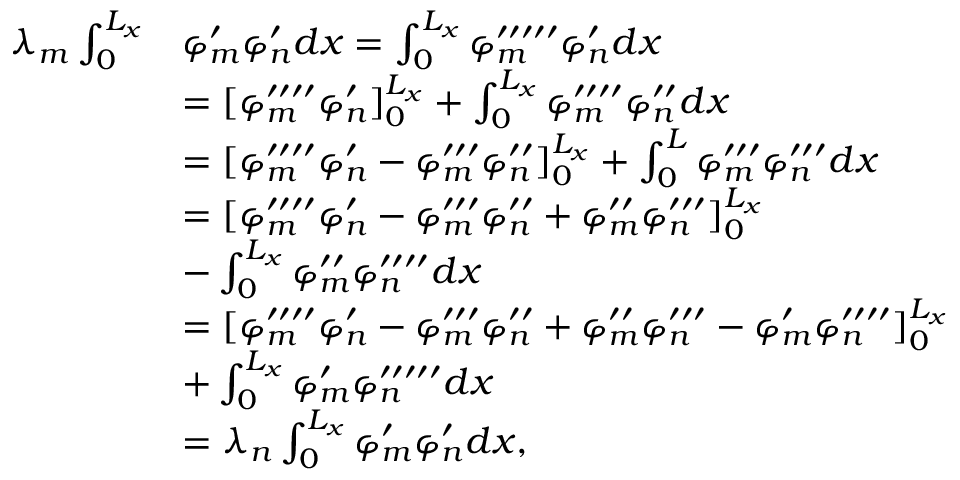Convert formula to latex. <formula><loc_0><loc_0><loc_500><loc_500>\begin{array} { r l } { \lambda _ { m } \int _ { 0 } ^ { L _ { x } } } & { \varphi _ { m } ^ { \prime } \varphi _ { n } ^ { \prime } d x = \int _ { 0 } ^ { L _ { x } } \varphi _ { m } ^ { \prime \prime \prime \prime \prime } \varphi _ { n } ^ { \prime } d x } \\ & { = [ \varphi _ { m } ^ { \prime \prime \prime \prime } \varphi _ { n } ^ { \prime } ] _ { 0 } ^ { L _ { x } } + \int _ { 0 } ^ { L _ { x } } \varphi _ { m } ^ { \prime \prime \prime \prime } \varphi _ { n } ^ { \prime \prime } d x } \\ & { = [ \varphi _ { m } ^ { \prime \prime \prime \prime } \varphi _ { n } ^ { \prime } - \varphi _ { m } ^ { \prime \prime \prime } \varphi _ { n } ^ { \prime \prime } ] _ { 0 } ^ { L _ { x } } + \int _ { 0 } ^ { L } \varphi _ { m } ^ { \prime \prime \prime } \varphi _ { n } ^ { \prime \prime \prime } d x } \\ & { = [ \varphi _ { m } ^ { \prime \prime \prime \prime } \varphi _ { n } ^ { \prime } - \varphi _ { m } ^ { \prime \prime \prime } \varphi _ { n } ^ { \prime \prime } + \varphi _ { m } ^ { \prime \prime } \varphi _ { n } ^ { \prime \prime \prime } ] _ { 0 } ^ { L _ { x } } } \\ & { - \int _ { 0 } ^ { L _ { x } } \varphi _ { m } ^ { \prime \prime } \varphi _ { n } ^ { \prime \prime \prime \prime } d x } \\ & { = [ \varphi _ { m } ^ { \prime \prime \prime \prime } \varphi _ { n } ^ { \prime } - \varphi _ { m } ^ { \prime \prime \prime } \varphi _ { n } ^ { \prime \prime } + \varphi _ { m } ^ { \prime \prime } \varphi _ { n } ^ { \prime \prime \prime } - \varphi _ { m } ^ { \prime } \varphi _ { n } ^ { \prime \prime \prime \prime } ] _ { 0 } ^ { L _ { x } } } \\ & { + \int _ { 0 } ^ { L _ { x } } \varphi _ { m } ^ { \prime } \varphi _ { n } ^ { \prime \prime \prime \prime \prime } d x } \\ & { = \lambda _ { n } \int _ { 0 } ^ { L _ { x } } \varphi _ { m } ^ { \prime } \varphi _ { n } ^ { \prime } d x , } \end{array}</formula> 